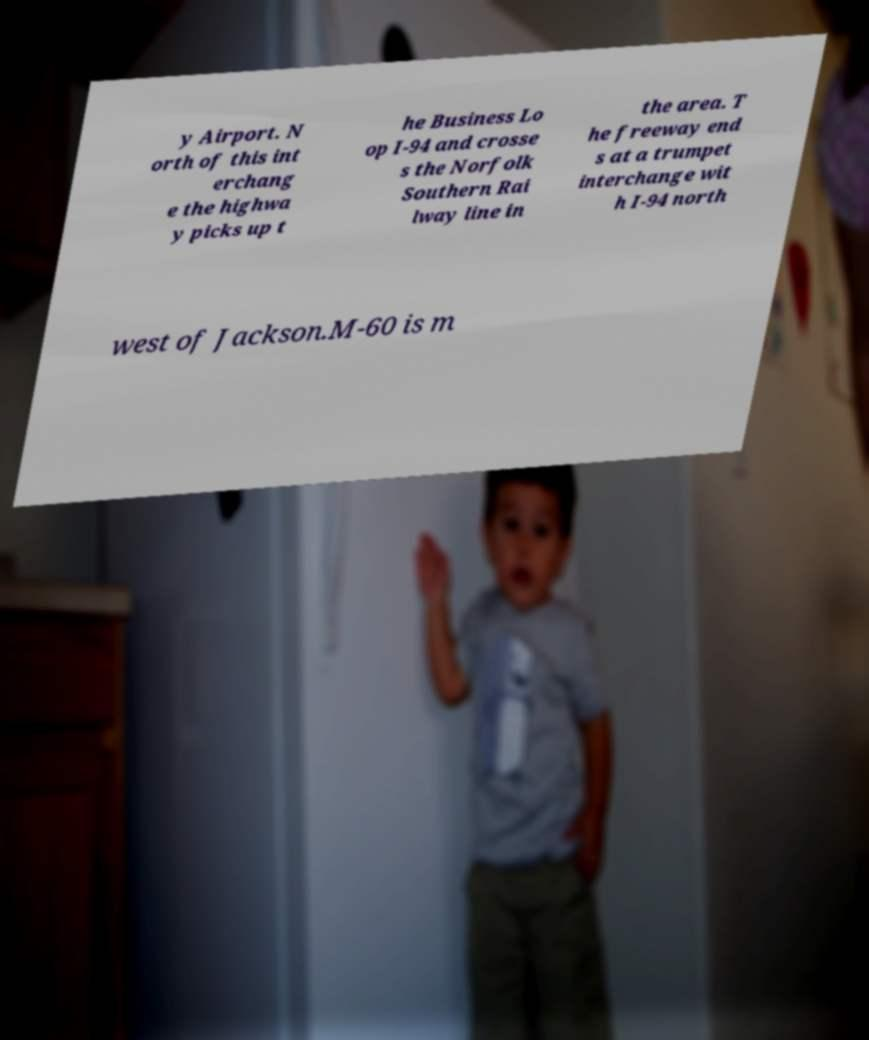Please identify and transcribe the text found in this image. y Airport. N orth of this int erchang e the highwa y picks up t he Business Lo op I-94 and crosse s the Norfolk Southern Rai lway line in the area. T he freeway end s at a trumpet interchange wit h I-94 north west of Jackson.M-60 is m 